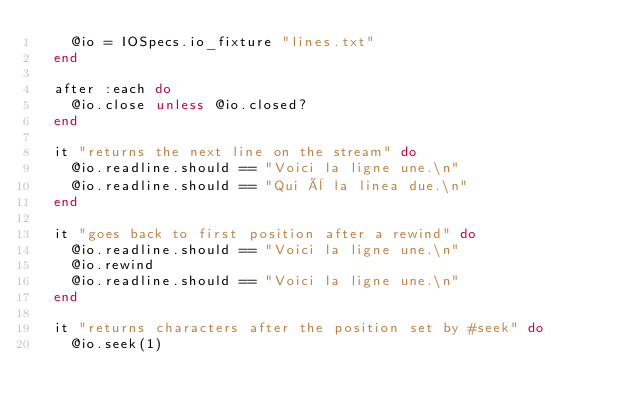<code> <loc_0><loc_0><loc_500><loc_500><_Ruby_>    @io = IOSpecs.io_fixture "lines.txt"
  end

  after :each do
    @io.close unless @io.closed?
  end

  it "returns the next line on the stream" do
    @io.readline.should == "Voici la ligne une.\n"
    @io.readline.should == "Qui è la linea due.\n"
  end

  it "goes back to first position after a rewind" do
    @io.readline.should == "Voici la ligne une.\n"
    @io.rewind
    @io.readline.should == "Voici la ligne une.\n"
  end

  it "returns characters after the position set by #seek" do
    @io.seek(1)</code> 